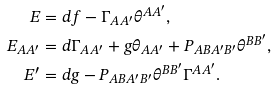<formula> <loc_0><loc_0><loc_500><loc_500>E & = d f - \Gamma _ { A A ^ { \prime } } \theta ^ { A A ^ { \prime } } , \\ E _ { A A ^ { \prime } } & = d \Gamma _ { A A ^ { \prime } } + g \theta _ { A A ^ { \prime } } + P _ { A B A ^ { \prime } B ^ { \prime } } \theta ^ { B B ^ { \prime } } , \\ E ^ { \prime } & = d g - P _ { A B A ^ { \prime } B ^ { \prime } } \theta ^ { B B ^ { \prime } } \Gamma ^ { A A ^ { \prime } } .</formula> 